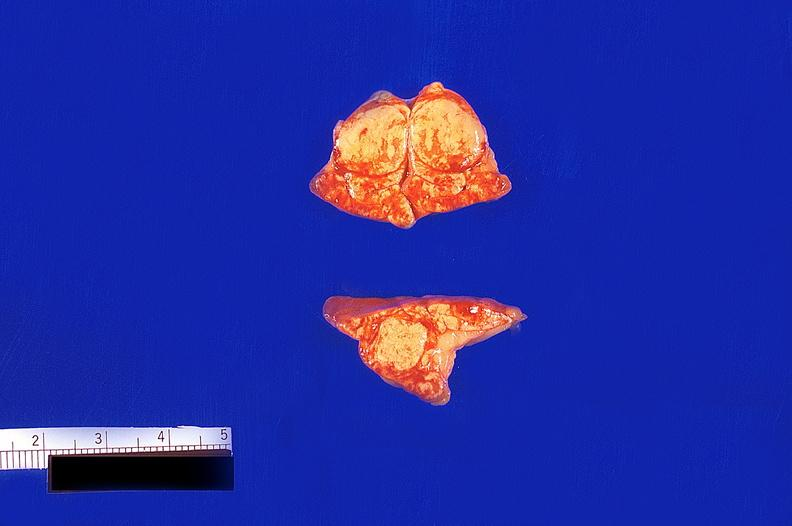s endocrine present?
Answer the question using a single word or phrase. Yes 